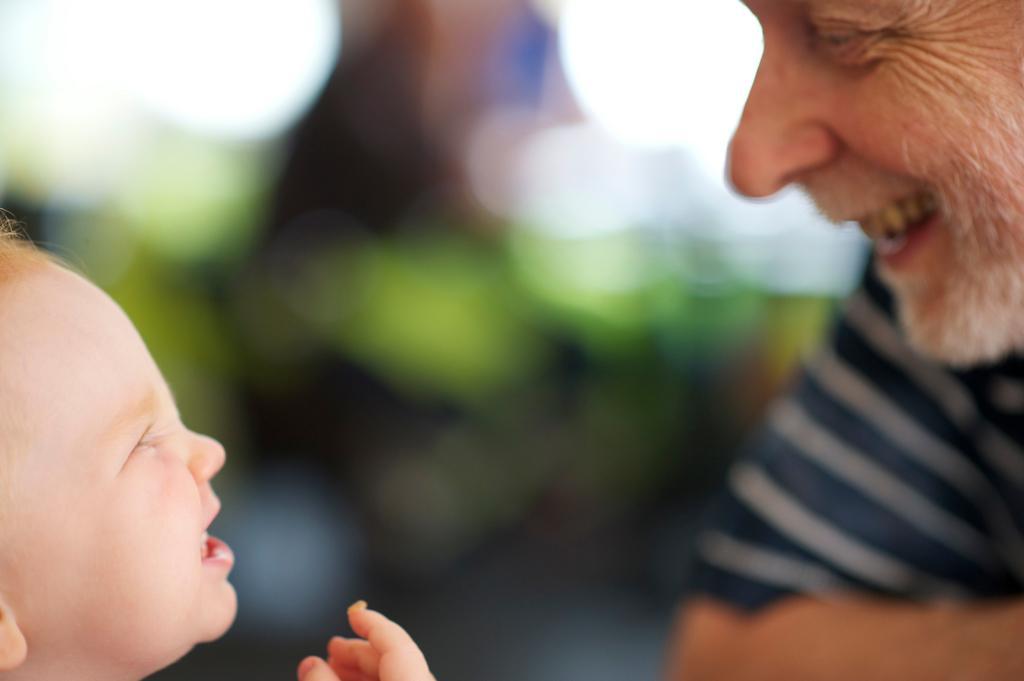Describe this image in one or two sentences. In this picture we can see a man and a child smiling and in the background it is blurry. 